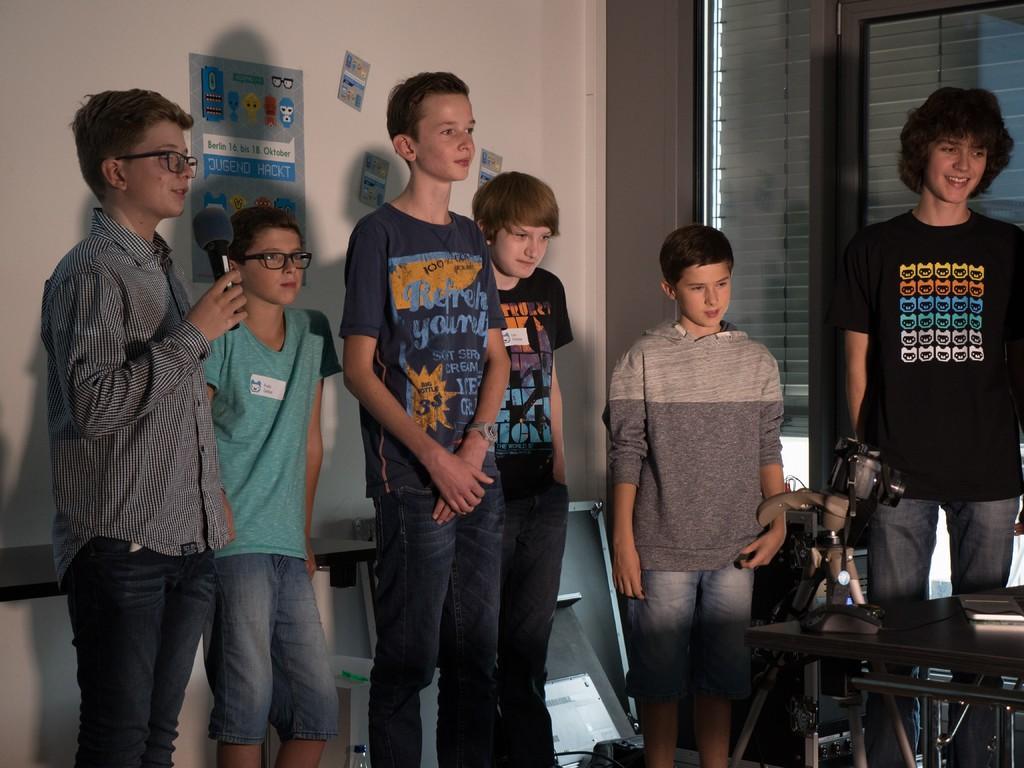Describe this image in one or two sentences. There are groups of people standing and smiling. This boy is holding a mike. These are the posters attached to the wall. I can see a book and a camera with the stand is placed on the table. This looks like a glass door. I think this is a curtain sheet hanging. 